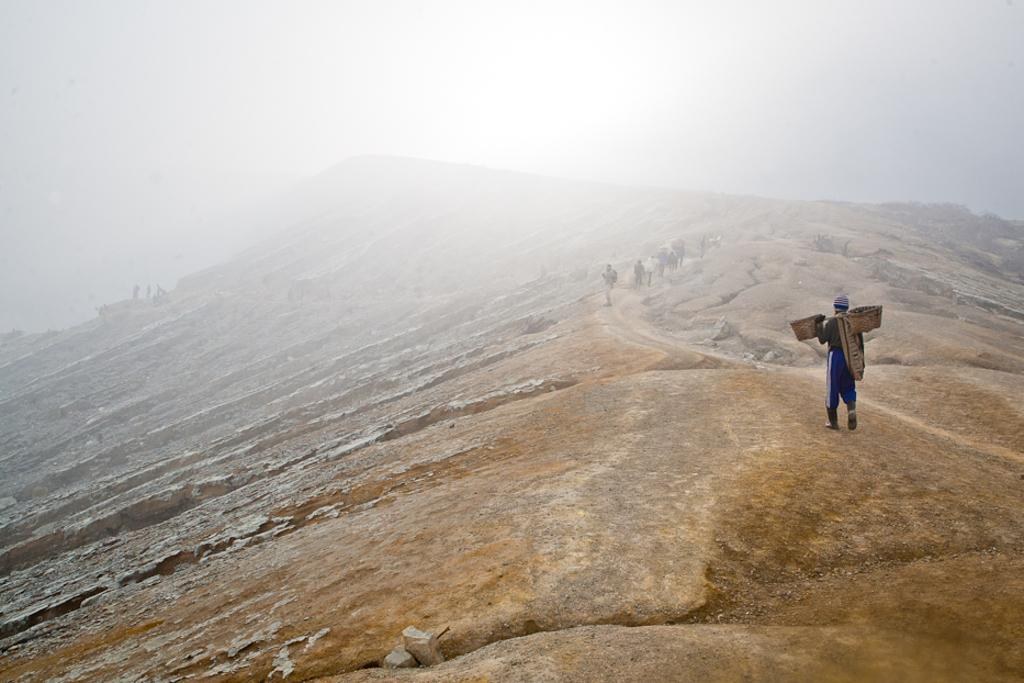Who or what can be seen in the image? There are people in the image. What are the people doing in the image? The people are walking on a mountain. What is the condition of the mountain in the image? The mountain has snow on it. What type of answer can be seen in the image? There is no answer present in the image; it features people walking on a snowy mountain. What kind of apparatus is being used by the people in the image? There is no apparatus visible in the image; the people are simply walking on the mountain. 